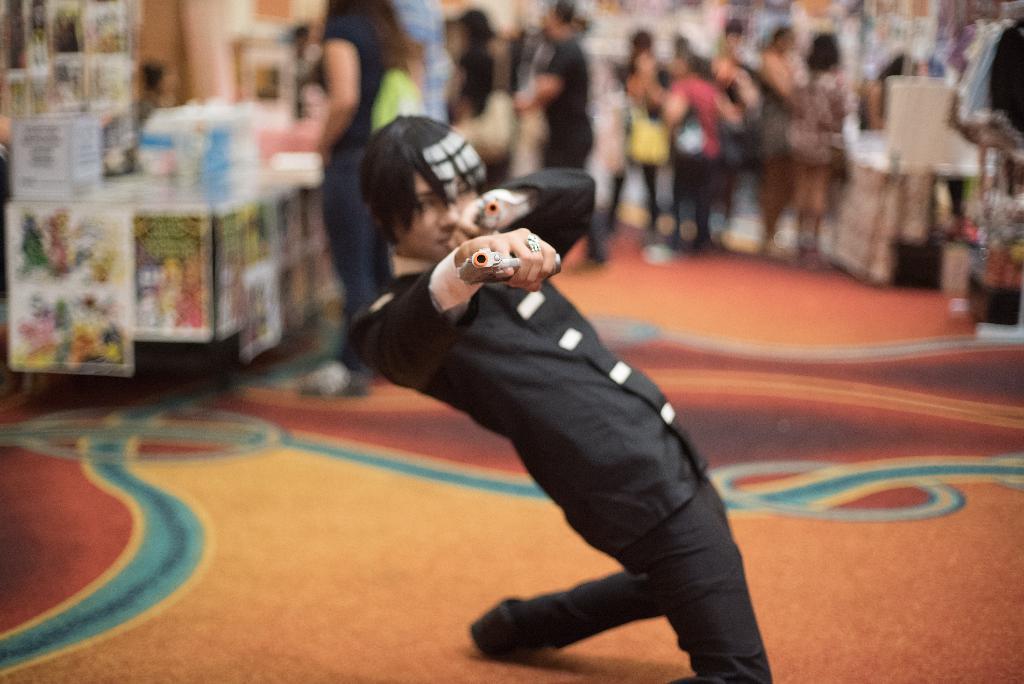Can you describe this image briefly? This picture describes about group of people, in the middle of the image we can see a man, he is holding a gun, beside to him we can find few posters and other things, and we can see blurry background. 